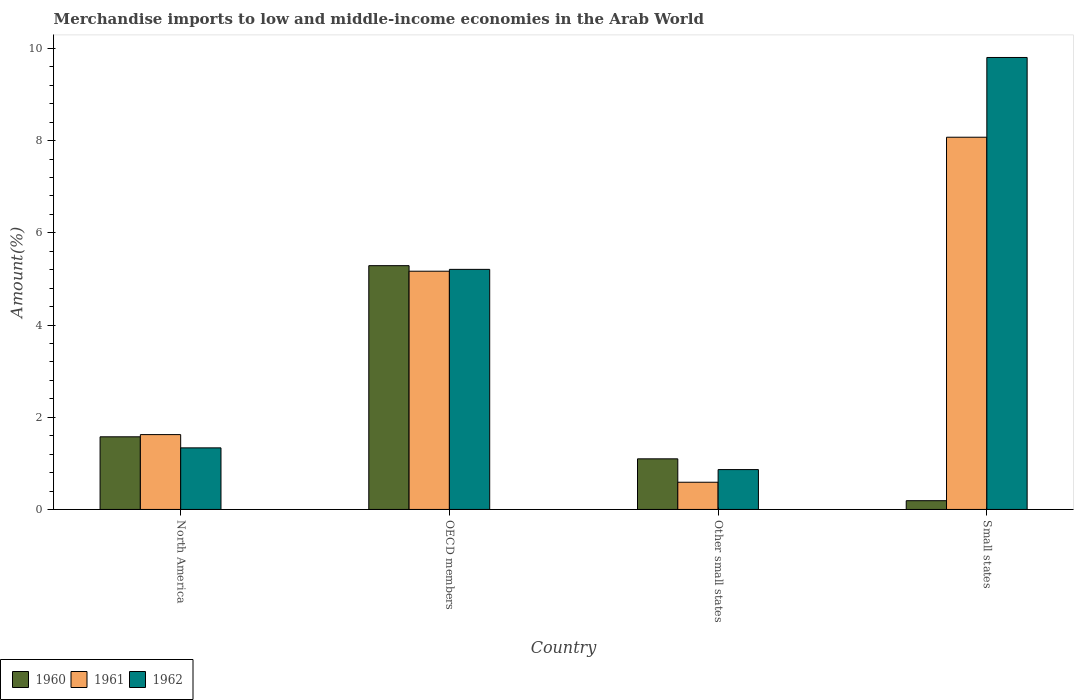Are the number of bars per tick equal to the number of legend labels?
Provide a succinct answer. Yes. How many bars are there on the 2nd tick from the left?
Your answer should be very brief. 3. How many bars are there on the 3rd tick from the right?
Give a very brief answer. 3. What is the label of the 3rd group of bars from the left?
Provide a succinct answer. Other small states. What is the percentage of amount earned from merchandise imports in 1962 in Other small states?
Your answer should be compact. 0.86. Across all countries, what is the maximum percentage of amount earned from merchandise imports in 1961?
Your answer should be very brief. 8.07. Across all countries, what is the minimum percentage of amount earned from merchandise imports in 1962?
Your answer should be compact. 0.86. In which country was the percentage of amount earned from merchandise imports in 1960 maximum?
Ensure brevity in your answer.  OECD members. In which country was the percentage of amount earned from merchandise imports in 1960 minimum?
Your answer should be very brief. Small states. What is the total percentage of amount earned from merchandise imports in 1962 in the graph?
Give a very brief answer. 17.21. What is the difference between the percentage of amount earned from merchandise imports in 1961 in Other small states and that in Small states?
Offer a terse response. -7.48. What is the difference between the percentage of amount earned from merchandise imports in 1961 in North America and the percentage of amount earned from merchandise imports in 1962 in Small states?
Your answer should be compact. -8.18. What is the average percentage of amount earned from merchandise imports in 1962 per country?
Offer a very short reply. 4.3. What is the difference between the percentage of amount earned from merchandise imports of/in 1961 and percentage of amount earned from merchandise imports of/in 1962 in Other small states?
Provide a succinct answer. -0.27. In how many countries, is the percentage of amount earned from merchandise imports in 1961 greater than 8.4 %?
Provide a succinct answer. 0. What is the ratio of the percentage of amount earned from merchandise imports in 1961 in North America to that in Other small states?
Your answer should be very brief. 2.75. Is the percentage of amount earned from merchandise imports in 1961 in Other small states less than that in Small states?
Keep it short and to the point. Yes. Is the difference between the percentage of amount earned from merchandise imports in 1961 in Other small states and Small states greater than the difference between the percentage of amount earned from merchandise imports in 1962 in Other small states and Small states?
Provide a short and direct response. Yes. What is the difference between the highest and the second highest percentage of amount earned from merchandise imports in 1960?
Your response must be concise. -3.71. What is the difference between the highest and the lowest percentage of amount earned from merchandise imports in 1960?
Provide a short and direct response. 5.1. In how many countries, is the percentage of amount earned from merchandise imports in 1961 greater than the average percentage of amount earned from merchandise imports in 1961 taken over all countries?
Give a very brief answer. 2. Is the sum of the percentage of amount earned from merchandise imports in 1960 in North America and Small states greater than the maximum percentage of amount earned from merchandise imports in 1962 across all countries?
Ensure brevity in your answer.  No. What does the 2nd bar from the left in North America represents?
Your answer should be very brief. 1961. What does the 3rd bar from the right in North America represents?
Provide a short and direct response. 1960. Is it the case that in every country, the sum of the percentage of amount earned from merchandise imports in 1961 and percentage of amount earned from merchandise imports in 1962 is greater than the percentage of amount earned from merchandise imports in 1960?
Offer a very short reply. Yes. Are all the bars in the graph horizontal?
Give a very brief answer. No. How many countries are there in the graph?
Keep it short and to the point. 4. What is the difference between two consecutive major ticks on the Y-axis?
Offer a terse response. 2. Are the values on the major ticks of Y-axis written in scientific E-notation?
Offer a terse response. No. Does the graph contain any zero values?
Keep it short and to the point. No. Does the graph contain grids?
Provide a short and direct response. No. How are the legend labels stacked?
Provide a short and direct response. Horizontal. What is the title of the graph?
Offer a terse response. Merchandise imports to low and middle-income economies in the Arab World. Does "1969" appear as one of the legend labels in the graph?
Provide a succinct answer. No. What is the label or title of the X-axis?
Your answer should be compact. Country. What is the label or title of the Y-axis?
Offer a terse response. Amount(%). What is the Amount(%) of 1960 in North America?
Your response must be concise. 1.58. What is the Amount(%) of 1961 in North America?
Your response must be concise. 1.62. What is the Amount(%) of 1962 in North America?
Your answer should be very brief. 1.34. What is the Amount(%) in 1960 in OECD members?
Your response must be concise. 5.29. What is the Amount(%) of 1961 in OECD members?
Your response must be concise. 5.17. What is the Amount(%) of 1962 in OECD members?
Your response must be concise. 5.21. What is the Amount(%) in 1960 in Other small states?
Keep it short and to the point. 1.1. What is the Amount(%) in 1961 in Other small states?
Your answer should be very brief. 0.59. What is the Amount(%) of 1962 in Other small states?
Offer a very short reply. 0.86. What is the Amount(%) in 1960 in Small states?
Provide a short and direct response. 0.19. What is the Amount(%) in 1961 in Small states?
Your response must be concise. 8.07. What is the Amount(%) of 1962 in Small states?
Provide a short and direct response. 9.8. Across all countries, what is the maximum Amount(%) in 1960?
Keep it short and to the point. 5.29. Across all countries, what is the maximum Amount(%) of 1961?
Ensure brevity in your answer.  8.07. Across all countries, what is the maximum Amount(%) in 1962?
Provide a short and direct response. 9.8. Across all countries, what is the minimum Amount(%) of 1960?
Make the answer very short. 0.19. Across all countries, what is the minimum Amount(%) of 1961?
Your response must be concise. 0.59. Across all countries, what is the minimum Amount(%) in 1962?
Offer a very short reply. 0.86. What is the total Amount(%) of 1960 in the graph?
Give a very brief answer. 8.15. What is the total Amount(%) of 1961 in the graph?
Offer a terse response. 15.45. What is the total Amount(%) of 1962 in the graph?
Ensure brevity in your answer.  17.21. What is the difference between the Amount(%) of 1960 in North America and that in OECD members?
Your response must be concise. -3.71. What is the difference between the Amount(%) of 1961 in North America and that in OECD members?
Provide a succinct answer. -3.54. What is the difference between the Amount(%) of 1962 in North America and that in OECD members?
Give a very brief answer. -3.87. What is the difference between the Amount(%) in 1960 in North America and that in Other small states?
Offer a very short reply. 0.48. What is the difference between the Amount(%) in 1961 in North America and that in Other small states?
Provide a succinct answer. 1.03. What is the difference between the Amount(%) of 1962 in North America and that in Other small states?
Offer a terse response. 0.47. What is the difference between the Amount(%) in 1960 in North America and that in Small states?
Your answer should be very brief. 1.39. What is the difference between the Amount(%) of 1961 in North America and that in Small states?
Keep it short and to the point. -6.45. What is the difference between the Amount(%) in 1962 in North America and that in Small states?
Make the answer very short. -8.47. What is the difference between the Amount(%) in 1960 in OECD members and that in Other small states?
Provide a succinct answer. 4.19. What is the difference between the Amount(%) of 1961 in OECD members and that in Other small states?
Ensure brevity in your answer.  4.58. What is the difference between the Amount(%) in 1962 in OECD members and that in Other small states?
Offer a very short reply. 4.34. What is the difference between the Amount(%) of 1960 in OECD members and that in Small states?
Provide a succinct answer. 5.1. What is the difference between the Amount(%) in 1961 in OECD members and that in Small states?
Your response must be concise. -2.91. What is the difference between the Amount(%) of 1962 in OECD members and that in Small states?
Provide a succinct answer. -4.6. What is the difference between the Amount(%) of 1960 in Other small states and that in Small states?
Offer a very short reply. 0.91. What is the difference between the Amount(%) in 1961 in Other small states and that in Small states?
Provide a short and direct response. -7.48. What is the difference between the Amount(%) of 1962 in Other small states and that in Small states?
Keep it short and to the point. -8.94. What is the difference between the Amount(%) of 1960 in North America and the Amount(%) of 1961 in OECD members?
Keep it short and to the point. -3.59. What is the difference between the Amount(%) in 1960 in North America and the Amount(%) in 1962 in OECD members?
Give a very brief answer. -3.63. What is the difference between the Amount(%) of 1961 in North America and the Amount(%) of 1962 in OECD members?
Your response must be concise. -3.58. What is the difference between the Amount(%) in 1960 in North America and the Amount(%) in 1961 in Other small states?
Make the answer very short. 0.99. What is the difference between the Amount(%) in 1960 in North America and the Amount(%) in 1962 in Other small states?
Make the answer very short. 0.71. What is the difference between the Amount(%) of 1961 in North America and the Amount(%) of 1962 in Other small states?
Offer a very short reply. 0.76. What is the difference between the Amount(%) in 1960 in North America and the Amount(%) in 1961 in Small states?
Make the answer very short. -6.5. What is the difference between the Amount(%) in 1960 in North America and the Amount(%) in 1962 in Small states?
Your answer should be very brief. -8.23. What is the difference between the Amount(%) of 1961 in North America and the Amount(%) of 1962 in Small states?
Offer a very short reply. -8.18. What is the difference between the Amount(%) of 1960 in OECD members and the Amount(%) of 1961 in Other small states?
Your answer should be compact. 4.7. What is the difference between the Amount(%) in 1960 in OECD members and the Amount(%) in 1962 in Other small states?
Make the answer very short. 4.42. What is the difference between the Amount(%) in 1961 in OECD members and the Amount(%) in 1962 in Other small states?
Ensure brevity in your answer.  4.3. What is the difference between the Amount(%) of 1960 in OECD members and the Amount(%) of 1961 in Small states?
Your response must be concise. -2.79. What is the difference between the Amount(%) of 1960 in OECD members and the Amount(%) of 1962 in Small states?
Offer a terse response. -4.51. What is the difference between the Amount(%) of 1961 in OECD members and the Amount(%) of 1962 in Small states?
Make the answer very short. -4.64. What is the difference between the Amount(%) in 1960 in Other small states and the Amount(%) in 1961 in Small states?
Your answer should be very brief. -6.97. What is the difference between the Amount(%) of 1960 in Other small states and the Amount(%) of 1962 in Small states?
Give a very brief answer. -8.7. What is the difference between the Amount(%) of 1961 in Other small states and the Amount(%) of 1962 in Small states?
Offer a very short reply. -9.21. What is the average Amount(%) in 1960 per country?
Offer a very short reply. 2.04. What is the average Amount(%) of 1961 per country?
Make the answer very short. 3.86. What is the average Amount(%) in 1962 per country?
Provide a succinct answer. 4.3. What is the difference between the Amount(%) in 1960 and Amount(%) in 1961 in North America?
Your response must be concise. -0.05. What is the difference between the Amount(%) of 1960 and Amount(%) of 1962 in North America?
Offer a very short reply. 0.24. What is the difference between the Amount(%) of 1961 and Amount(%) of 1962 in North America?
Ensure brevity in your answer.  0.29. What is the difference between the Amount(%) of 1960 and Amount(%) of 1961 in OECD members?
Make the answer very short. 0.12. What is the difference between the Amount(%) in 1960 and Amount(%) in 1962 in OECD members?
Keep it short and to the point. 0.08. What is the difference between the Amount(%) in 1961 and Amount(%) in 1962 in OECD members?
Your response must be concise. -0.04. What is the difference between the Amount(%) of 1960 and Amount(%) of 1961 in Other small states?
Provide a succinct answer. 0.51. What is the difference between the Amount(%) of 1960 and Amount(%) of 1962 in Other small states?
Keep it short and to the point. 0.23. What is the difference between the Amount(%) of 1961 and Amount(%) of 1962 in Other small states?
Your answer should be compact. -0.27. What is the difference between the Amount(%) in 1960 and Amount(%) in 1961 in Small states?
Your response must be concise. -7.88. What is the difference between the Amount(%) of 1960 and Amount(%) of 1962 in Small states?
Offer a terse response. -9.61. What is the difference between the Amount(%) in 1961 and Amount(%) in 1962 in Small states?
Provide a short and direct response. -1.73. What is the ratio of the Amount(%) in 1960 in North America to that in OECD members?
Keep it short and to the point. 0.3. What is the ratio of the Amount(%) in 1961 in North America to that in OECD members?
Offer a terse response. 0.31. What is the ratio of the Amount(%) of 1962 in North America to that in OECD members?
Keep it short and to the point. 0.26. What is the ratio of the Amount(%) in 1960 in North America to that in Other small states?
Offer a very short reply. 1.44. What is the ratio of the Amount(%) of 1961 in North America to that in Other small states?
Provide a succinct answer. 2.75. What is the ratio of the Amount(%) of 1962 in North America to that in Other small states?
Offer a terse response. 1.54. What is the ratio of the Amount(%) of 1960 in North America to that in Small states?
Provide a succinct answer. 8.3. What is the ratio of the Amount(%) in 1961 in North America to that in Small states?
Give a very brief answer. 0.2. What is the ratio of the Amount(%) of 1962 in North America to that in Small states?
Make the answer very short. 0.14. What is the ratio of the Amount(%) in 1960 in OECD members to that in Other small states?
Your answer should be compact. 4.82. What is the ratio of the Amount(%) in 1961 in OECD members to that in Other small states?
Give a very brief answer. 8.76. What is the ratio of the Amount(%) in 1962 in OECD members to that in Other small states?
Ensure brevity in your answer.  6.02. What is the ratio of the Amount(%) of 1960 in OECD members to that in Small states?
Your answer should be very brief. 27.86. What is the ratio of the Amount(%) in 1961 in OECD members to that in Small states?
Make the answer very short. 0.64. What is the ratio of the Amount(%) in 1962 in OECD members to that in Small states?
Your answer should be compact. 0.53. What is the ratio of the Amount(%) in 1960 in Other small states to that in Small states?
Give a very brief answer. 5.78. What is the ratio of the Amount(%) of 1961 in Other small states to that in Small states?
Offer a terse response. 0.07. What is the ratio of the Amount(%) in 1962 in Other small states to that in Small states?
Make the answer very short. 0.09. What is the difference between the highest and the second highest Amount(%) of 1960?
Keep it short and to the point. 3.71. What is the difference between the highest and the second highest Amount(%) of 1961?
Make the answer very short. 2.91. What is the difference between the highest and the second highest Amount(%) in 1962?
Your answer should be very brief. 4.6. What is the difference between the highest and the lowest Amount(%) of 1960?
Give a very brief answer. 5.1. What is the difference between the highest and the lowest Amount(%) in 1961?
Give a very brief answer. 7.48. What is the difference between the highest and the lowest Amount(%) in 1962?
Your answer should be compact. 8.94. 